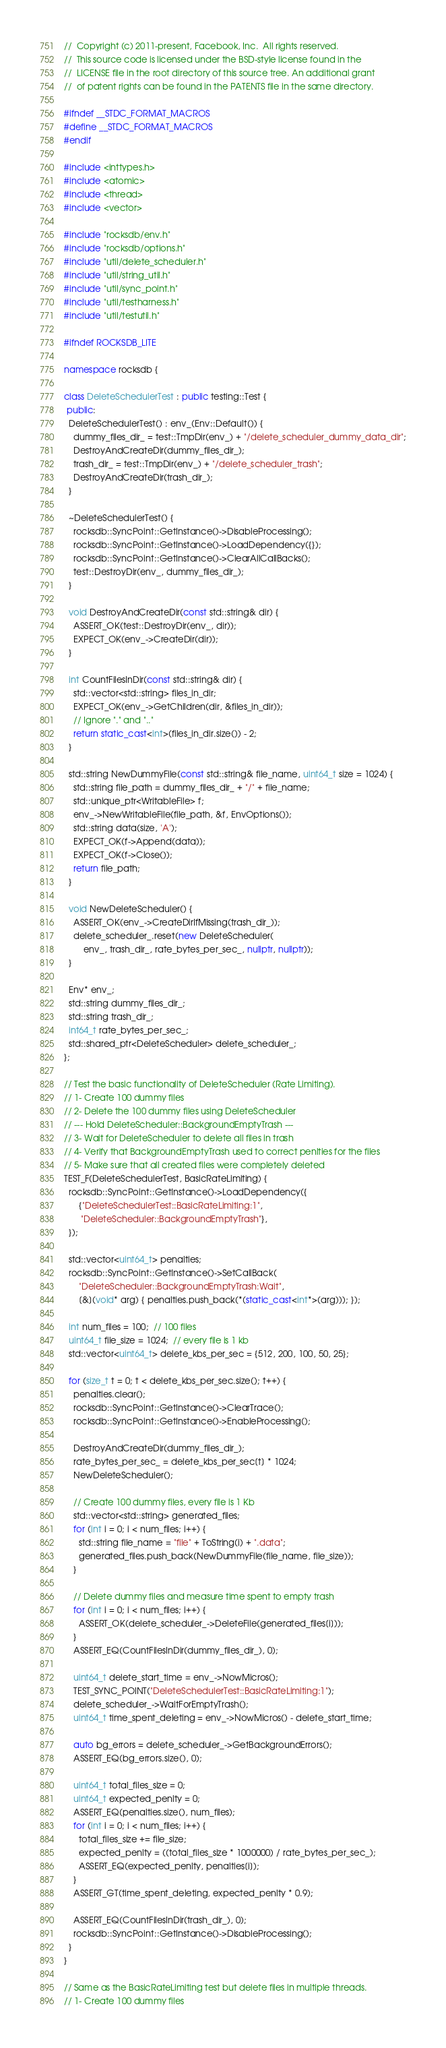<code> <loc_0><loc_0><loc_500><loc_500><_C++_>//  Copyright (c) 2011-present, Facebook, Inc.  All rights reserved.
//  This source code is licensed under the BSD-style license found in the
//  LICENSE file in the root directory of this source tree. An additional grant
//  of patent rights can be found in the PATENTS file in the same directory.

#ifndef __STDC_FORMAT_MACROS
#define __STDC_FORMAT_MACROS
#endif

#include <inttypes.h>
#include <atomic>
#include <thread>
#include <vector>

#include "rocksdb/env.h"
#include "rocksdb/options.h"
#include "util/delete_scheduler.h"
#include "util/string_util.h"
#include "util/sync_point.h"
#include "util/testharness.h"
#include "util/testutil.h"

#ifndef ROCKSDB_LITE

namespace rocksdb {

class DeleteSchedulerTest : public testing::Test {
 public:
  DeleteSchedulerTest() : env_(Env::Default()) {
    dummy_files_dir_ = test::TmpDir(env_) + "/delete_scheduler_dummy_data_dir";
    DestroyAndCreateDir(dummy_files_dir_);
    trash_dir_ = test::TmpDir(env_) + "/delete_scheduler_trash";
    DestroyAndCreateDir(trash_dir_);
  }

  ~DeleteSchedulerTest() {
    rocksdb::SyncPoint::GetInstance()->DisableProcessing();
    rocksdb::SyncPoint::GetInstance()->LoadDependency({});
    rocksdb::SyncPoint::GetInstance()->ClearAllCallBacks();
    test::DestroyDir(env_, dummy_files_dir_);
  }

  void DestroyAndCreateDir(const std::string& dir) {
    ASSERT_OK(test::DestroyDir(env_, dir));
    EXPECT_OK(env_->CreateDir(dir));
  }

  int CountFilesInDir(const std::string& dir) {
    std::vector<std::string> files_in_dir;
    EXPECT_OK(env_->GetChildren(dir, &files_in_dir));
    // Ignore "." and ".."
    return static_cast<int>(files_in_dir.size()) - 2;
  }

  std::string NewDummyFile(const std::string& file_name, uint64_t size = 1024) {
    std::string file_path = dummy_files_dir_ + "/" + file_name;
    std::unique_ptr<WritableFile> f;
    env_->NewWritableFile(file_path, &f, EnvOptions());
    std::string data(size, 'A');
    EXPECT_OK(f->Append(data));
    EXPECT_OK(f->Close());
    return file_path;
  }

  void NewDeleteScheduler() {
    ASSERT_OK(env_->CreateDirIfMissing(trash_dir_));
    delete_scheduler_.reset(new DeleteScheduler(
        env_, trash_dir_, rate_bytes_per_sec_, nullptr, nullptr));
  }

  Env* env_;
  std::string dummy_files_dir_;
  std::string trash_dir_;
  int64_t rate_bytes_per_sec_;
  std::shared_ptr<DeleteScheduler> delete_scheduler_;
};

// Test the basic functionality of DeleteScheduler (Rate Limiting).
// 1- Create 100 dummy files
// 2- Delete the 100 dummy files using DeleteScheduler
// --- Hold DeleteScheduler::BackgroundEmptyTrash ---
// 3- Wait for DeleteScheduler to delete all files in trash
// 4- Verify that BackgroundEmptyTrash used to correct penlties for the files
// 5- Make sure that all created files were completely deleted
TEST_F(DeleteSchedulerTest, BasicRateLimiting) {
  rocksdb::SyncPoint::GetInstance()->LoadDependency({
      {"DeleteSchedulerTest::BasicRateLimiting:1",
       "DeleteScheduler::BackgroundEmptyTrash"},
  });

  std::vector<uint64_t> penalties;
  rocksdb::SyncPoint::GetInstance()->SetCallBack(
      "DeleteScheduler::BackgroundEmptyTrash:Wait",
      [&](void* arg) { penalties.push_back(*(static_cast<int*>(arg))); });

  int num_files = 100;  // 100 files
  uint64_t file_size = 1024;  // every file is 1 kb
  std::vector<uint64_t> delete_kbs_per_sec = {512, 200, 100, 50, 25};

  for (size_t t = 0; t < delete_kbs_per_sec.size(); t++) {
    penalties.clear();
    rocksdb::SyncPoint::GetInstance()->ClearTrace();
    rocksdb::SyncPoint::GetInstance()->EnableProcessing();

    DestroyAndCreateDir(dummy_files_dir_);
    rate_bytes_per_sec_ = delete_kbs_per_sec[t] * 1024;
    NewDeleteScheduler();

    // Create 100 dummy files, every file is 1 Kb
    std::vector<std::string> generated_files;
    for (int i = 0; i < num_files; i++) {
      std::string file_name = "file" + ToString(i) + ".data";
      generated_files.push_back(NewDummyFile(file_name, file_size));
    }

    // Delete dummy files and measure time spent to empty trash
    for (int i = 0; i < num_files; i++) {
      ASSERT_OK(delete_scheduler_->DeleteFile(generated_files[i]));
    }
    ASSERT_EQ(CountFilesInDir(dummy_files_dir_), 0);

    uint64_t delete_start_time = env_->NowMicros();
    TEST_SYNC_POINT("DeleteSchedulerTest::BasicRateLimiting:1");
    delete_scheduler_->WaitForEmptyTrash();
    uint64_t time_spent_deleting = env_->NowMicros() - delete_start_time;

    auto bg_errors = delete_scheduler_->GetBackgroundErrors();
    ASSERT_EQ(bg_errors.size(), 0);

    uint64_t total_files_size = 0;
    uint64_t expected_penlty = 0;
    ASSERT_EQ(penalties.size(), num_files);
    for (int i = 0; i < num_files; i++) {
      total_files_size += file_size;
      expected_penlty = ((total_files_size * 1000000) / rate_bytes_per_sec_);
      ASSERT_EQ(expected_penlty, penalties[i]);
    }
    ASSERT_GT(time_spent_deleting, expected_penlty * 0.9);

    ASSERT_EQ(CountFilesInDir(trash_dir_), 0);
    rocksdb::SyncPoint::GetInstance()->DisableProcessing();
  }
}

// Same as the BasicRateLimiting test but delete files in multiple threads.
// 1- Create 100 dummy files</code> 